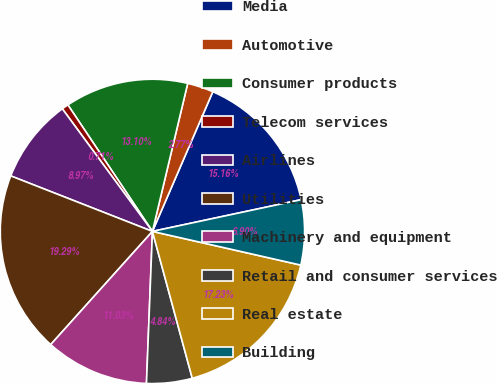<chart> <loc_0><loc_0><loc_500><loc_500><pie_chart><fcel>Media<fcel>Automotive<fcel>Consumer products<fcel>Telecom services<fcel>Airlines<fcel>Utilities<fcel>Machinery and equipment<fcel>Retail and consumer services<fcel>Real estate<fcel>Building<nl><fcel>15.16%<fcel>2.77%<fcel>13.1%<fcel>0.71%<fcel>8.97%<fcel>19.29%<fcel>11.03%<fcel>4.84%<fcel>17.23%<fcel>6.9%<nl></chart> 